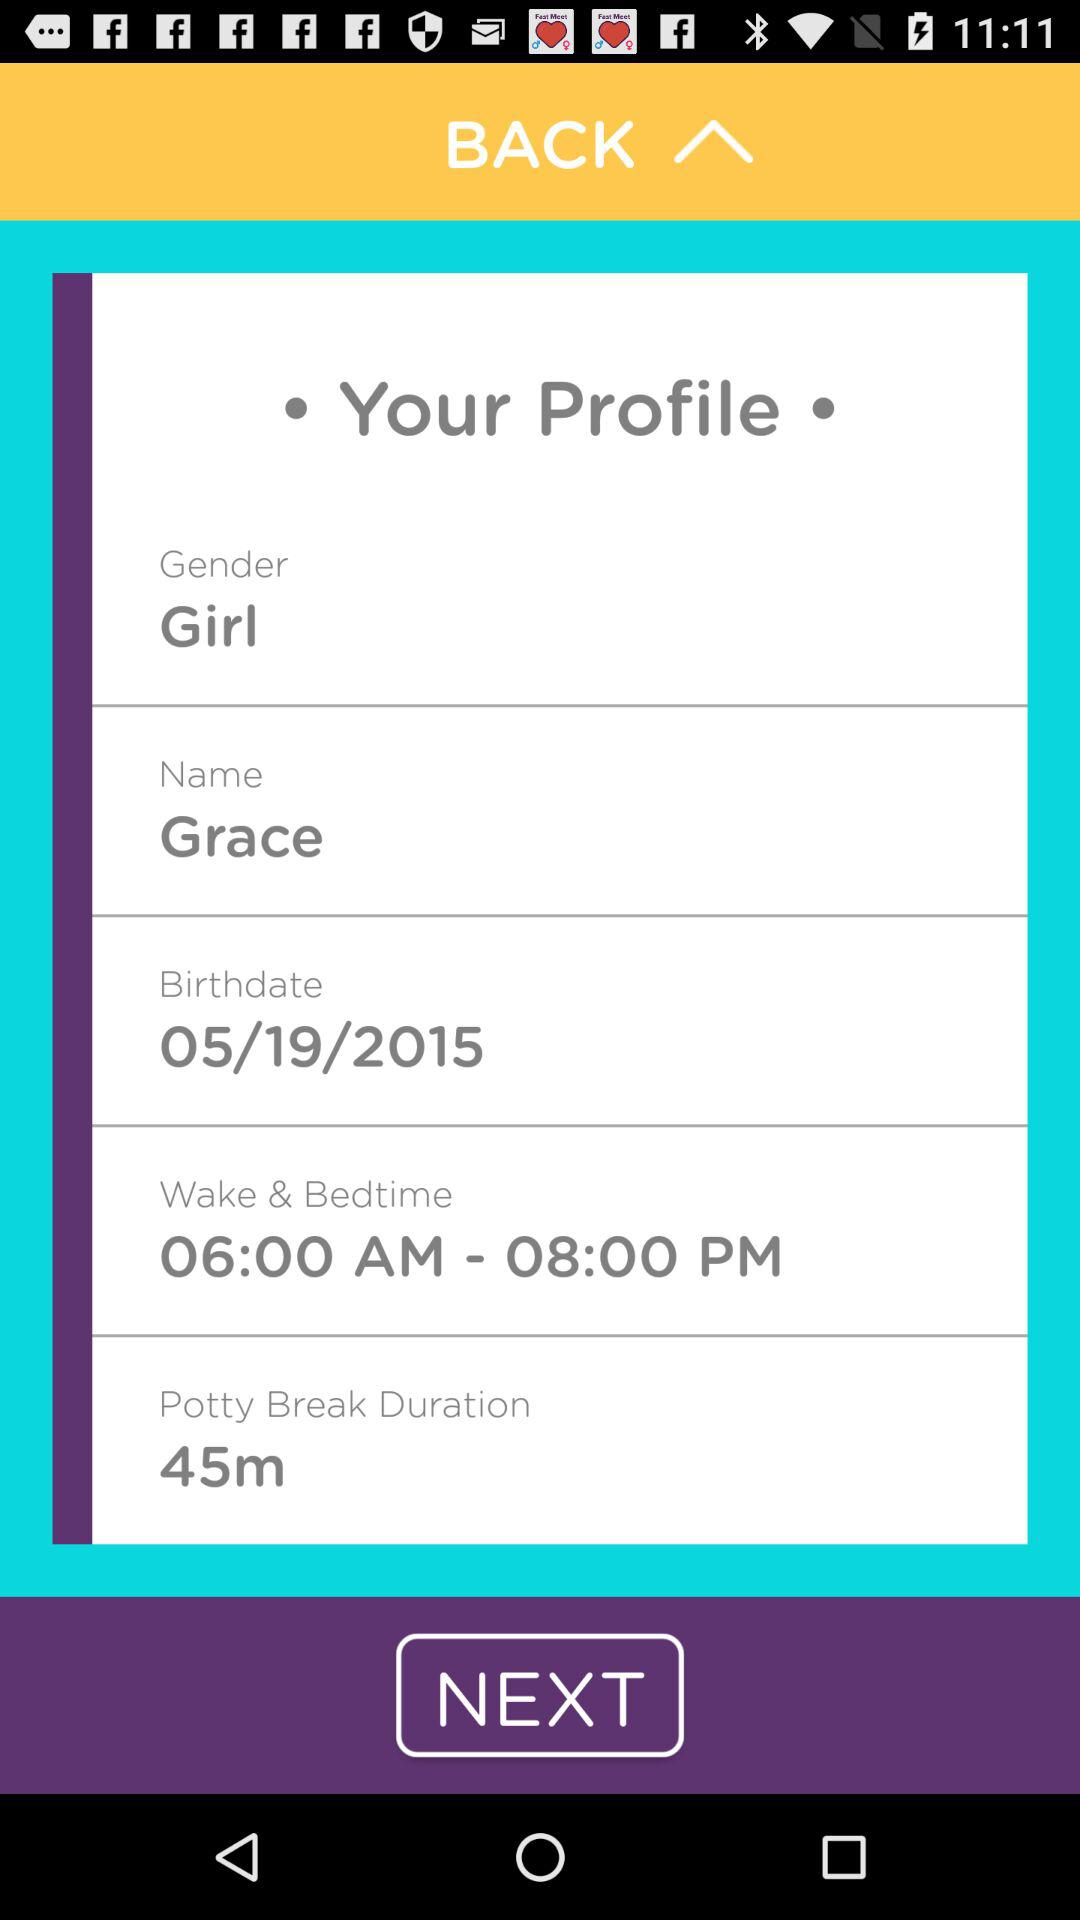What is the potty break time duration? The potty break time duration is 45 minutes. 